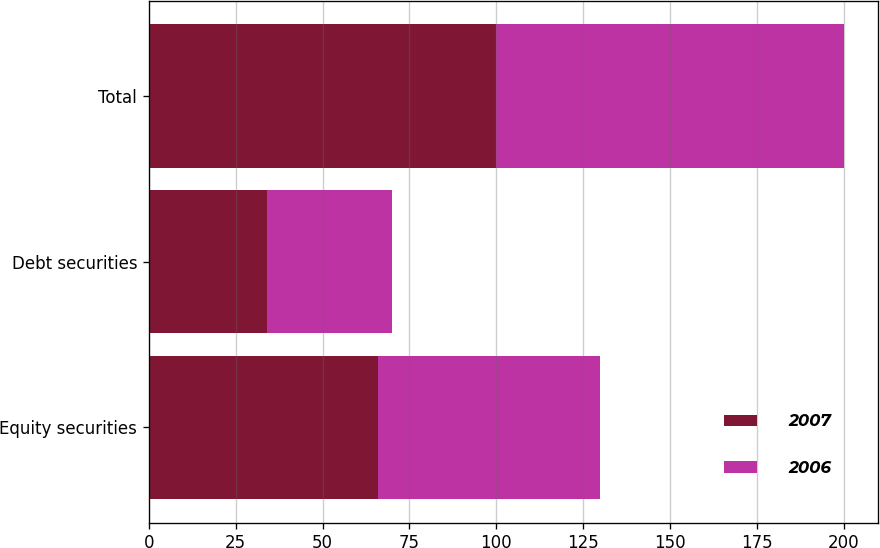Convert chart. <chart><loc_0><loc_0><loc_500><loc_500><stacked_bar_chart><ecel><fcel>Equity securities<fcel>Debt securities<fcel>Total<nl><fcel>2007<fcel>66<fcel>34<fcel>100<nl><fcel>2006<fcel>64<fcel>36<fcel>100<nl></chart> 